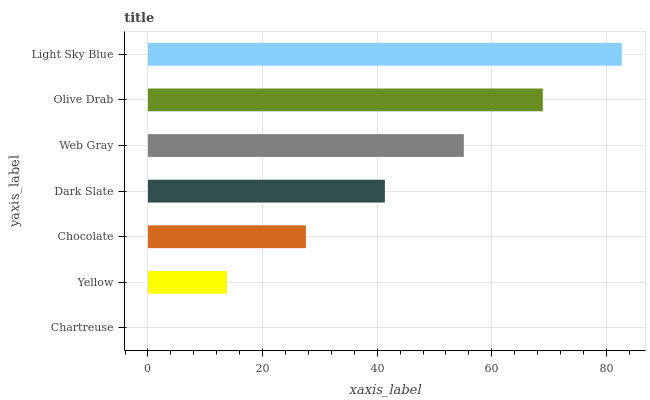Is Chartreuse the minimum?
Answer yes or no. Yes. Is Light Sky Blue the maximum?
Answer yes or no. Yes. Is Yellow the minimum?
Answer yes or no. No. Is Yellow the maximum?
Answer yes or no. No. Is Yellow greater than Chartreuse?
Answer yes or no. Yes. Is Chartreuse less than Yellow?
Answer yes or no. Yes. Is Chartreuse greater than Yellow?
Answer yes or no. No. Is Yellow less than Chartreuse?
Answer yes or no. No. Is Dark Slate the high median?
Answer yes or no. Yes. Is Dark Slate the low median?
Answer yes or no. Yes. Is Olive Drab the high median?
Answer yes or no. No. Is Chartreuse the low median?
Answer yes or no. No. 